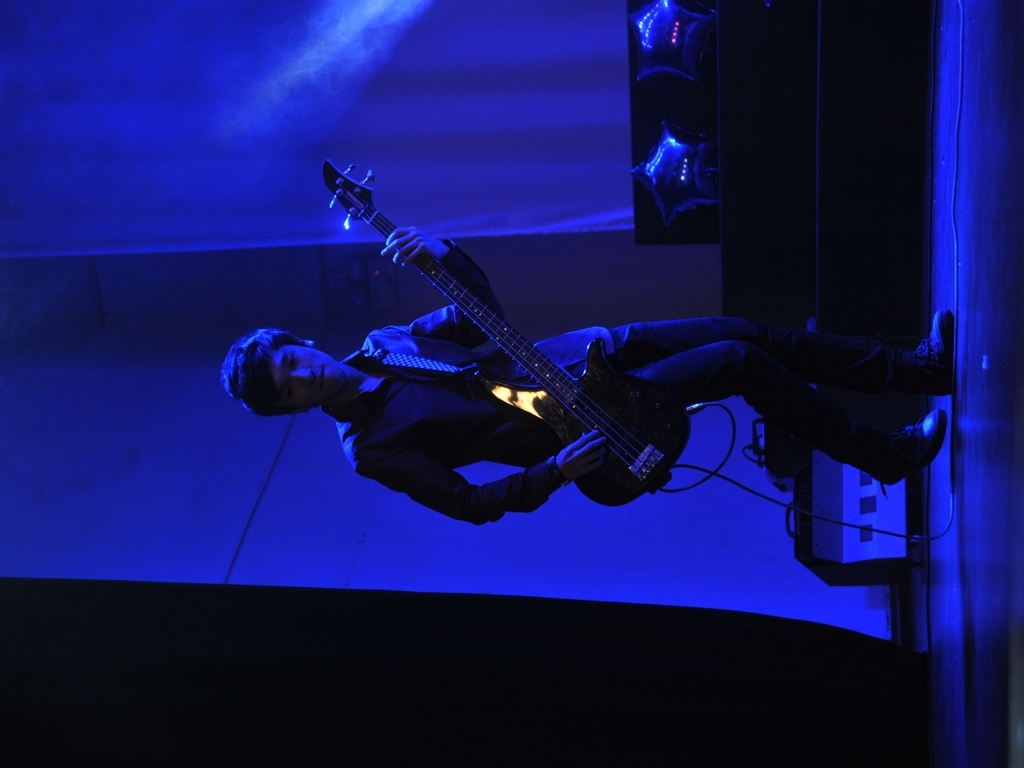Are the details good? The image showcases a musician immersed in performance with his bass guitar, bathed in moody blue stage lighting that creates a dramatic and focused atmosphere. The composition highlights his concentration and the energy of the live music experience. While the details in the darker areas are somewhat obscured by the low lighting, this effect adds to the intimate and intense feel of the scene, capturing a common reality in such performances. 